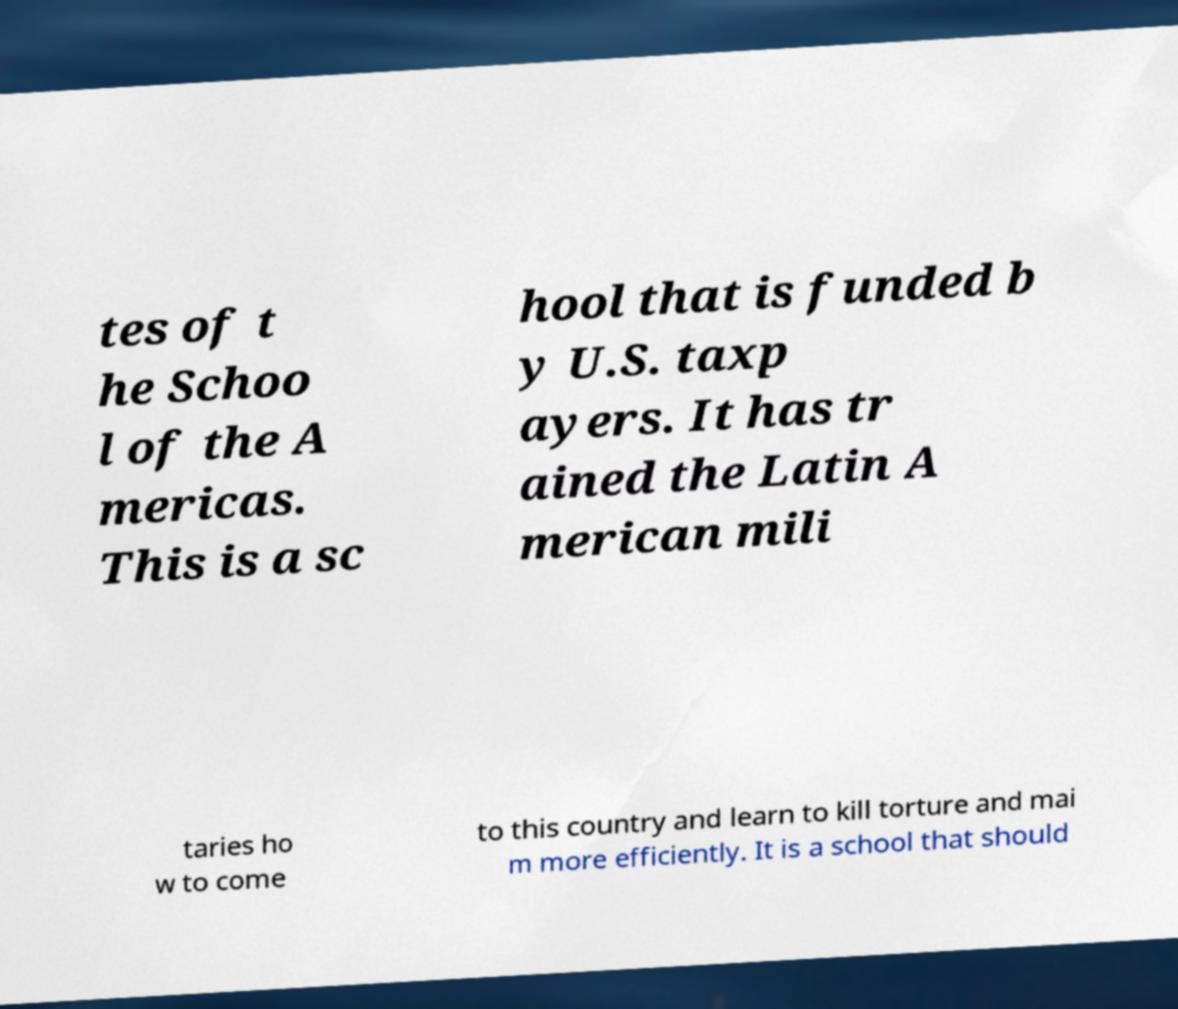For documentation purposes, I need the text within this image transcribed. Could you provide that? tes of t he Schoo l of the A mericas. This is a sc hool that is funded b y U.S. taxp ayers. It has tr ained the Latin A merican mili taries ho w to come to this country and learn to kill torture and mai m more efficiently. It is a school that should 